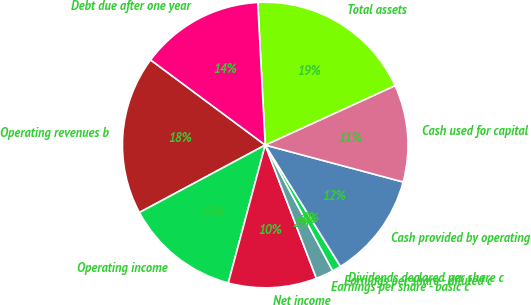Convert chart to OTSL. <chart><loc_0><loc_0><loc_500><loc_500><pie_chart><fcel>Operating revenues b<fcel>Operating income<fcel>Net income<fcel>Earnings per share - basic c<fcel>Earnings per share - diluted c<fcel>Dividends declared per share c<fcel>Cash provided by operating<fcel>Cash used for capital<fcel>Total assets<fcel>Debt due after one year<nl><fcel>18.0%<fcel>13.0%<fcel>10.0%<fcel>2.0%<fcel>1.0%<fcel>0.0%<fcel>12.0%<fcel>11.0%<fcel>19.0%<fcel>14.0%<nl></chart> 